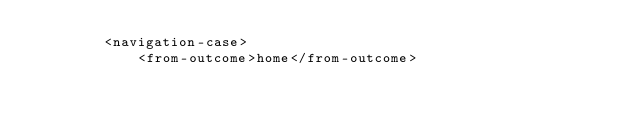Convert code to text. <code><loc_0><loc_0><loc_500><loc_500><_XML_>        <navigation-case>
            <from-outcome>home</from-outcome></code> 